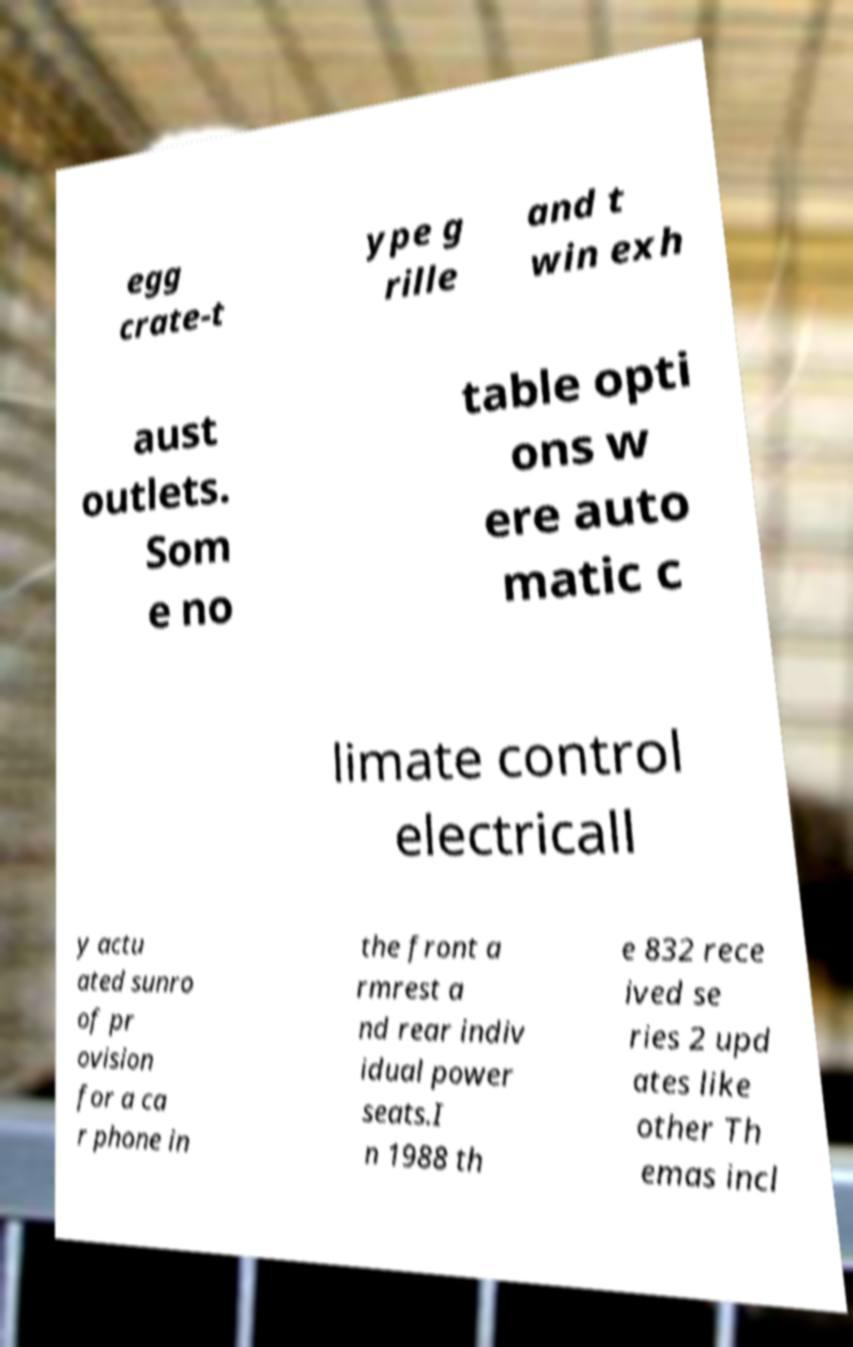For documentation purposes, I need the text within this image transcribed. Could you provide that? egg crate-t ype g rille and t win exh aust outlets. Som e no table opti ons w ere auto matic c limate control electricall y actu ated sunro of pr ovision for a ca r phone in the front a rmrest a nd rear indiv idual power seats.I n 1988 th e 832 rece ived se ries 2 upd ates like other Th emas incl 